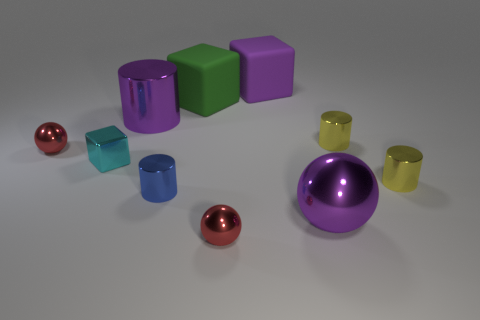What number of other blue objects have the same shape as the blue object?
Your answer should be very brief. 0. Is the number of shiny things on the right side of the purple metallic cylinder greater than the number of purple cylinders?
Keep it short and to the point. Yes. The large purple thing that is in front of the red ball that is behind the red metallic ball in front of the small cyan block is what shape?
Provide a short and direct response. Sphere. There is a tiny red object to the left of the green object; is it the same shape as the tiny red metallic thing to the right of the cyan cube?
Provide a short and direct response. Yes. Is there anything else that is the same size as the blue thing?
Ensure brevity in your answer.  Yes. What number of cylinders are either large metallic things or cyan things?
Give a very brief answer. 1. Is the material of the big cylinder the same as the green object?
Offer a terse response. No. How many other things are there of the same color as the large metal cylinder?
Provide a succinct answer. 2. What is the shape of the small red metal thing that is on the left side of the purple cylinder?
Keep it short and to the point. Sphere. What number of things are big red shiny cylinders or large purple rubber objects?
Give a very brief answer. 1. 